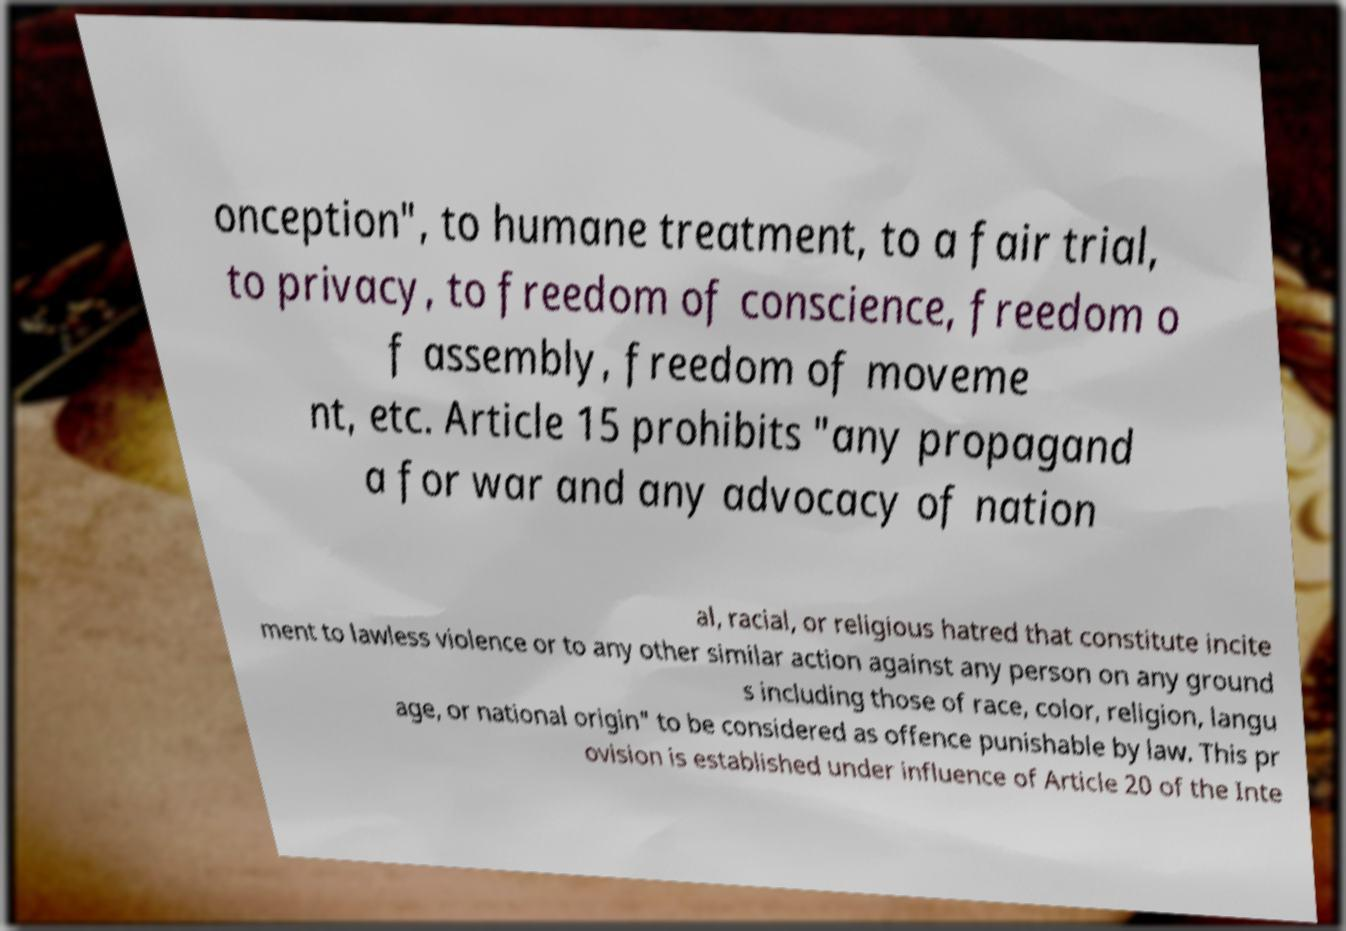I need the written content from this picture converted into text. Can you do that? onception", to humane treatment, to a fair trial, to privacy, to freedom of conscience, freedom o f assembly, freedom of moveme nt, etc. Article 15 prohibits "any propagand a for war and any advocacy of nation al, racial, or religious hatred that constitute incite ment to lawless violence or to any other similar action against any person on any ground s including those of race, color, religion, langu age, or national origin" to be considered as offence punishable by law. This pr ovision is established under influence of Article 20 of the Inte 